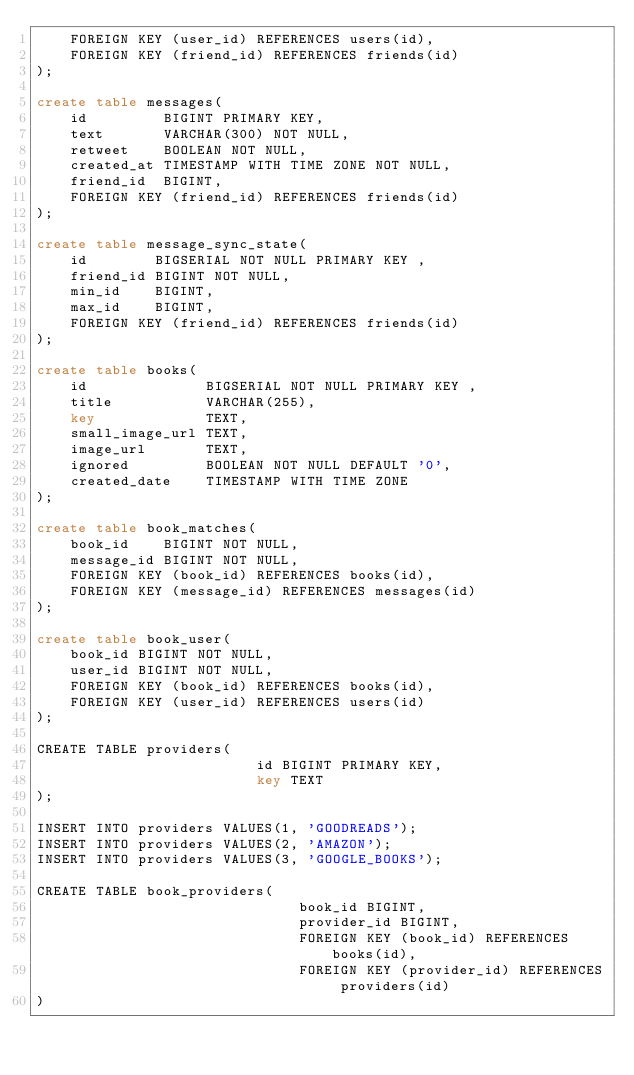Convert code to text. <code><loc_0><loc_0><loc_500><loc_500><_SQL_>    FOREIGN KEY (user_id) REFERENCES users(id),
    FOREIGN KEY (friend_id) REFERENCES friends(id)
);

create table messages(
    id         BIGINT PRIMARY KEY,
    text       VARCHAR(300) NOT NULL,
    retweet    BOOLEAN NOT NULL,
    created_at TIMESTAMP WITH TIME ZONE NOT NULL,
    friend_id  BIGINT,
    FOREIGN KEY (friend_id) REFERENCES friends(id)
);

create table message_sync_state(
    id        BIGSERIAL NOT NULL PRIMARY KEY ,
    friend_id BIGINT NOT NULL,
    min_id    BIGINT,
    max_id    BIGINT,
    FOREIGN KEY (friend_id) REFERENCES friends(id)
);

create table books(
    id              BIGSERIAL NOT NULL PRIMARY KEY ,
    title           VARCHAR(255),
    key             TEXT,
    small_image_url TEXT,
    image_url       TEXT,
    ignored         BOOLEAN NOT NULL DEFAULT '0',
    created_date    TIMESTAMP WITH TIME ZONE
);

create table book_matches(
    book_id    BIGINT NOT NULL,
    message_id BIGINT NOT NULL,
    FOREIGN KEY (book_id) REFERENCES books(id),
    FOREIGN KEY (message_id) REFERENCES messages(id)
);

create table book_user(
    book_id BIGINT NOT NULL,
    user_id BIGINT NOT NULL,
    FOREIGN KEY (book_id) REFERENCES books(id),
    FOREIGN KEY (user_id) REFERENCES users(id)
);

CREATE TABLE providers(
                          id BIGINT PRIMARY KEY,
                          key TEXT
);

INSERT INTO providers VALUES(1, 'GOODREADS');
INSERT INTO providers VALUES(2, 'AMAZON');
INSERT INTO providers VALUES(3, 'GOOGLE_BOOKS');

CREATE TABLE book_providers(
                               book_id BIGINT,
                               provider_id BIGINT,
                               FOREIGN KEY (book_id) REFERENCES books(id),
                               FOREIGN KEY (provider_id) REFERENCES providers(id)
)
</code> 